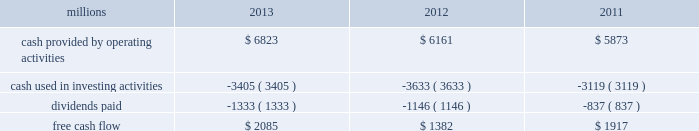Increase in dividends paid .
Free cash flow is defined as cash provided by operating activities less cash used in investing activities and dividends paid .
Free cash flow is not considered a financial measure under accounting principles generally accepted in the u.s .
( gaap ) by sec regulation g and item 10 of sec regulation s-k and may not be defined and calculated by other companies in the same manner .
We believe free cash flow is important to management and investors in evaluating our financial performance and measures our ability to generate cash without additional external financings .
Free cash flow should be considered in addition to , rather than as a substitute for , cash provided by operating activities .
The table reconciles cash provided by operating activities ( gaap measure ) to free cash flow ( non-gaap measure ) : millions 2013 2012 2011 .
2014 outlook f0b7 safety 2013 operating a safe railroad benefits our employees , our customers , our shareholders , and the communities we serve .
We will continue using a multi-faceted approach to safety , utilizing technology , risk assessment , quality control , training and employee engagement , and targeted capital investments .
We will continue using and expanding the deployment of total safety culture and courage to care throughout our operations , which allows us to identify and implement best practices for employee and operational safety .
Derailment prevention and the reduction of grade crossing incidents are also critical aspects of our safety programs .
We will continue our efforts to increase detection of rail defects ; improve or close crossings ; and educate the public and law enforcement agencies about crossing safety through a combination of our own programs ( including risk assessment strategies ) , various industry programs and local community activities across our network .
F0b7 network operations 2013 we believe the railroad is capable of handling growing volumes while providing high levels of customer service .
Our track structure is in excellent condition , and certain sections of our network have surplus line and terminal capacity .
We are in a solid resource position , with sufficient supplies of locomotives , freight cars and crews to support growth .
F0b7 fuel prices 2013 uncertainty about the economy makes projections of fuel prices difficult .
We again could see volatile fuel prices during the year , as they are sensitive to global and u.s .
Domestic demand , refining capacity , geopolitical events , weather conditions and other factors .
To reduce the impact of fuel price on earnings , we will continue seeking cost recovery from our customers through our fuel surcharge programs and expanding our fuel conservation efforts .
F0b7 capital plan 2013 in 2014 , we plan to make total capital investments of approximately $ 3.9 billion , including expenditures for positive train control ( ptc ) , which may be revised if business conditions warrant or if new laws or regulations affect our ability to generate sufficient returns on these investments .
( see further discussion in this item 7 under liquidity and capital resources 2013 capital plan. ) f0b7 positive train control 2013 in response to a legislative mandate to implement ptc by the end of 2015 , we have invested $ 1.2 billion in capital expenditures and plan to spend an additional $ 450 million during 2014 on developing and deploying ptc .
We currently estimate that ptc , in accordance with implementing rules issued by the federal rail administration ( fra ) , will cost us approximately $ 2 billion by the end of the project .
This includes costs for installing the new system along our tracks , upgrading locomotives to work with the new system , and adding digital data communication equipment to integrate the various components of the system and achieve interoperability for the industry .
Although it is unlikely that the rail industry will meet the current mandatory 2015 deadline ( as the fra indicated in its 2012 report to congress ) , we are making a good faith effort to do so and we are working closely with regulators as we implement this new technology. .
What was the average cash provided by operating activities from 2011 to 2013? 
Computations: (((6823 + 6161) + 5873) / 3)
Answer: 6285.66667. Increase in dividends paid .
Free cash flow is defined as cash provided by operating activities less cash used in investing activities and dividends paid .
Free cash flow is not considered a financial measure under accounting principles generally accepted in the u.s .
( gaap ) by sec regulation g and item 10 of sec regulation s-k and may not be defined and calculated by other companies in the same manner .
We believe free cash flow is important to management and investors in evaluating our financial performance and measures our ability to generate cash without additional external financings .
Free cash flow should be considered in addition to , rather than as a substitute for , cash provided by operating activities .
The table reconciles cash provided by operating activities ( gaap measure ) to free cash flow ( non-gaap measure ) : millions 2013 2012 2011 .
2014 outlook f0b7 safety 2013 operating a safe railroad benefits our employees , our customers , our shareholders , and the communities we serve .
We will continue using a multi-faceted approach to safety , utilizing technology , risk assessment , quality control , training and employee engagement , and targeted capital investments .
We will continue using and expanding the deployment of total safety culture and courage to care throughout our operations , which allows us to identify and implement best practices for employee and operational safety .
Derailment prevention and the reduction of grade crossing incidents are also critical aspects of our safety programs .
We will continue our efforts to increase detection of rail defects ; improve or close crossings ; and educate the public and law enforcement agencies about crossing safety through a combination of our own programs ( including risk assessment strategies ) , various industry programs and local community activities across our network .
F0b7 network operations 2013 we believe the railroad is capable of handling growing volumes while providing high levels of customer service .
Our track structure is in excellent condition , and certain sections of our network have surplus line and terminal capacity .
We are in a solid resource position , with sufficient supplies of locomotives , freight cars and crews to support growth .
F0b7 fuel prices 2013 uncertainty about the economy makes projections of fuel prices difficult .
We again could see volatile fuel prices during the year , as they are sensitive to global and u.s .
Domestic demand , refining capacity , geopolitical events , weather conditions and other factors .
To reduce the impact of fuel price on earnings , we will continue seeking cost recovery from our customers through our fuel surcharge programs and expanding our fuel conservation efforts .
F0b7 capital plan 2013 in 2014 , we plan to make total capital investments of approximately $ 3.9 billion , including expenditures for positive train control ( ptc ) , which may be revised if business conditions warrant or if new laws or regulations affect our ability to generate sufficient returns on these investments .
( see further discussion in this item 7 under liquidity and capital resources 2013 capital plan. ) f0b7 positive train control 2013 in response to a legislative mandate to implement ptc by the end of 2015 , we have invested $ 1.2 billion in capital expenditures and plan to spend an additional $ 450 million during 2014 on developing and deploying ptc .
We currently estimate that ptc , in accordance with implementing rules issued by the federal rail administration ( fra ) , will cost us approximately $ 2 billion by the end of the project .
This includes costs for installing the new system along our tracks , upgrading locomotives to work with the new system , and adding digital data communication equipment to integrate the various components of the system and achieve interoperability for the industry .
Although it is unlikely that the rail industry will meet the current mandatory 2015 deadline ( as the fra indicated in its 2012 report to congress ) , we are making a good faith effort to do so and we are working closely with regulators as we implement this new technology. .
What percentage of cash provided by operating activities were dividends paid in 2012? 
Rationale: looking to see what kind of cash coverage the firm has to pay its dividend from its operations .
Computations: (1146 / 6161)
Answer: 0.18601. 